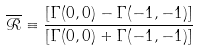<formula> <loc_0><loc_0><loc_500><loc_500>\overline { { \mathcal { R } } } \equiv \frac { [ { \Gamma } ( 0 , 0 ) - { \Gamma } ( - 1 , - 1 ) ] } { [ { \Gamma } ( 0 , 0 ) + { \Gamma } ( - 1 , - 1 ) ] }</formula> 